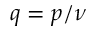<formula> <loc_0><loc_0><loc_500><loc_500>q = p / \nu</formula> 